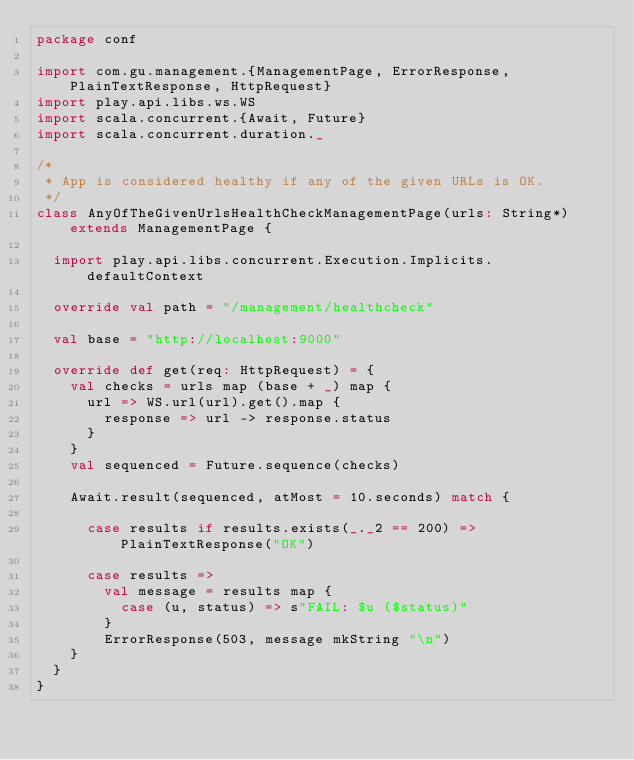Convert code to text. <code><loc_0><loc_0><loc_500><loc_500><_Scala_>package conf

import com.gu.management.{ManagementPage, ErrorResponse, PlainTextResponse, HttpRequest}
import play.api.libs.ws.WS
import scala.concurrent.{Await, Future}
import scala.concurrent.duration._

/*
 * App is considered healthy if any of the given URLs is OK.
 */
class AnyOfTheGivenUrlsHealthCheckManagementPage(urls: String*) extends ManagementPage {

  import play.api.libs.concurrent.Execution.Implicits.defaultContext

  override val path = "/management/healthcheck"

  val base = "http://localhost:9000"

  override def get(req: HttpRequest) = {
    val checks = urls map (base + _) map {
      url => WS.url(url).get().map {
        response => url -> response.status
      }
    }
    val sequenced = Future.sequence(checks)

    Await.result(sequenced, atMost = 10.seconds) match {

      case results if results.exists(_._2 == 200) => PlainTextResponse("OK")

      case results =>
        val message = results map {
          case (u, status) => s"FAIL: $u ($status)"
        }
        ErrorResponse(503, message mkString "\n")
    }
  }
}
</code> 